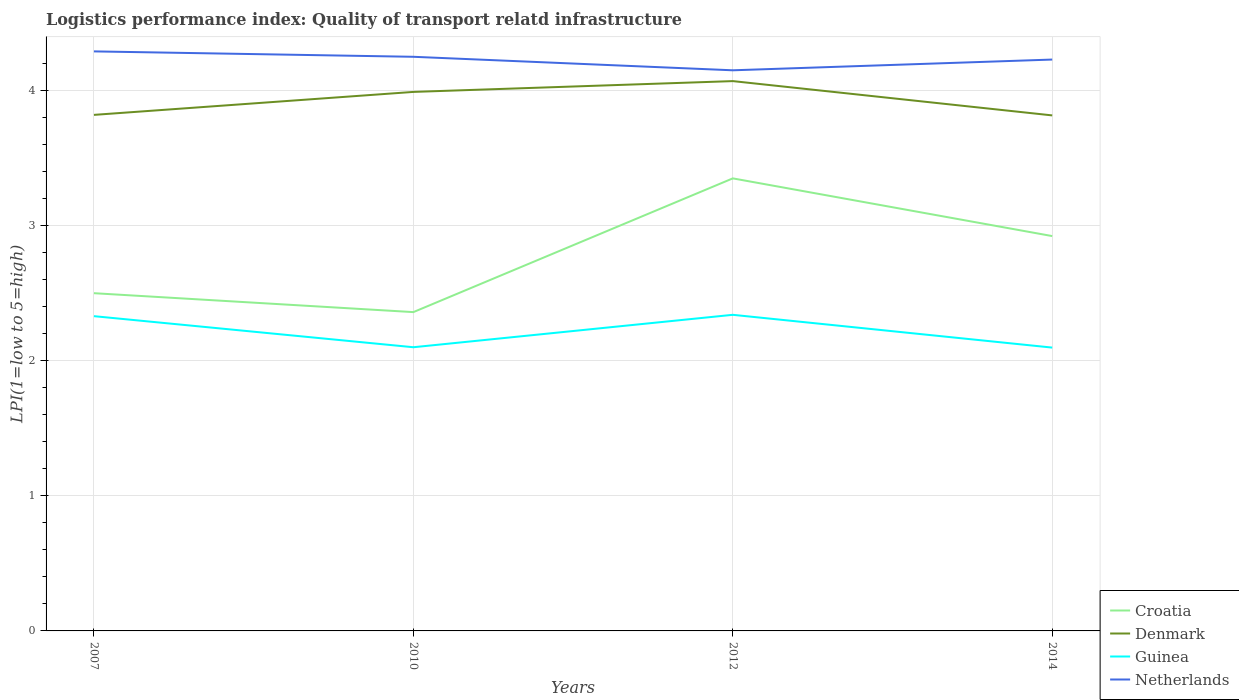How many different coloured lines are there?
Provide a succinct answer. 4. Does the line corresponding to Denmark intersect with the line corresponding to Croatia?
Your answer should be very brief. No. Is the number of lines equal to the number of legend labels?
Give a very brief answer. Yes. Across all years, what is the maximum logistics performance index in Denmark?
Offer a terse response. 3.82. What is the total logistics performance index in Netherlands in the graph?
Make the answer very short. -0.08. What is the difference between the highest and the second highest logistics performance index in Denmark?
Make the answer very short. 0.25. Is the logistics performance index in Guinea strictly greater than the logistics performance index in Denmark over the years?
Your response must be concise. Yes. Does the graph contain any zero values?
Offer a terse response. No. Does the graph contain grids?
Your response must be concise. Yes. How are the legend labels stacked?
Your answer should be very brief. Vertical. What is the title of the graph?
Provide a short and direct response. Logistics performance index: Quality of transport relatd infrastructure. Does "Argentina" appear as one of the legend labels in the graph?
Make the answer very short. No. What is the label or title of the X-axis?
Your answer should be compact. Years. What is the label or title of the Y-axis?
Your answer should be very brief. LPI(1=low to 5=high). What is the LPI(1=low to 5=high) of Denmark in 2007?
Provide a succinct answer. 3.82. What is the LPI(1=low to 5=high) of Guinea in 2007?
Your answer should be very brief. 2.33. What is the LPI(1=low to 5=high) of Netherlands in 2007?
Ensure brevity in your answer.  4.29. What is the LPI(1=low to 5=high) of Croatia in 2010?
Provide a succinct answer. 2.36. What is the LPI(1=low to 5=high) of Denmark in 2010?
Provide a succinct answer. 3.99. What is the LPI(1=low to 5=high) in Netherlands in 2010?
Your answer should be compact. 4.25. What is the LPI(1=low to 5=high) of Croatia in 2012?
Your response must be concise. 3.35. What is the LPI(1=low to 5=high) of Denmark in 2012?
Your answer should be very brief. 4.07. What is the LPI(1=low to 5=high) of Guinea in 2012?
Offer a terse response. 2.34. What is the LPI(1=low to 5=high) in Netherlands in 2012?
Provide a succinct answer. 4.15. What is the LPI(1=low to 5=high) of Croatia in 2014?
Make the answer very short. 2.92. What is the LPI(1=low to 5=high) in Denmark in 2014?
Give a very brief answer. 3.82. What is the LPI(1=low to 5=high) in Guinea in 2014?
Your answer should be compact. 2.1. What is the LPI(1=low to 5=high) in Netherlands in 2014?
Ensure brevity in your answer.  4.23. Across all years, what is the maximum LPI(1=low to 5=high) of Croatia?
Your response must be concise. 3.35. Across all years, what is the maximum LPI(1=low to 5=high) of Denmark?
Keep it short and to the point. 4.07. Across all years, what is the maximum LPI(1=low to 5=high) in Guinea?
Your answer should be compact. 2.34. Across all years, what is the maximum LPI(1=low to 5=high) in Netherlands?
Make the answer very short. 4.29. Across all years, what is the minimum LPI(1=low to 5=high) in Croatia?
Your response must be concise. 2.36. Across all years, what is the minimum LPI(1=low to 5=high) of Denmark?
Give a very brief answer. 3.82. Across all years, what is the minimum LPI(1=low to 5=high) of Guinea?
Offer a terse response. 2.1. Across all years, what is the minimum LPI(1=low to 5=high) in Netherlands?
Your response must be concise. 4.15. What is the total LPI(1=low to 5=high) in Croatia in the graph?
Your answer should be compact. 11.13. What is the total LPI(1=low to 5=high) in Denmark in the graph?
Offer a terse response. 15.7. What is the total LPI(1=low to 5=high) of Guinea in the graph?
Provide a succinct answer. 8.87. What is the total LPI(1=low to 5=high) of Netherlands in the graph?
Your answer should be very brief. 16.92. What is the difference between the LPI(1=low to 5=high) in Croatia in 2007 and that in 2010?
Make the answer very short. 0.14. What is the difference between the LPI(1=low to 5=high) in Denmark in 2007 and that in 2010?
Give a very brief answer. -0.17. What is the difference between the LPI(1=low to 5=high) in Guinea in 2007 and that in 2010?
Offer a very short reply. 0.23. What is the difference between the LPI(1=low to 5=high) in Croatia in 2007 and that in 2012?
Provide a succinct answer. -0.85. What is the difference between the LPI(1=low to 5=high) of Denmark in 2007 and that in 2012?
Keep it short and to the point. -0.25. What is the difference between the LPI(1=low to 5=high) in Guinea in 2007 and that in 2012?
Your answer should be compact. -0.01. What is the difference between the LPI(1=low to 5=high) in Netherlands in 2007 and that in 2012?
Provide a short and direct response. 0.14. What is the difference between the LPI(1=low to 5=high) of Croatia in 2007 and that in 2014?
Provide a succinct answer. -0.42. What is the difference between the LPI(1=low to 5=high) of Denmark in 2007 and that in 2014?
Offer a very short reply. 0. What is the difference between the LPI(1=low to 5=high) in Guinea in 2007 and that in 2014?
Offer a very short reply. 0.23. What is the difference between the LPI(1=low to 5=high) in Netherlands in 2007 and that in 2014?
Keep it short and to the point. 0.06. What is the difference between the LPI(1=low to 5=high) in Croatia in 2010 and that in 2012?
Give a very brief answer. -0.99. What is the difference between the LPI(1=low to 5=high) in Denmark in 2010 and that in 2012?
Ensure brevity in your answer.  -0.08. What is the difference between the LPI(1=low to 5=high) in Guinea in 2010 and that in 2012?
Keep it short and to the point. -0.24. What is the difference between the LPI(1=low to 5=high) in Netherlands in 2010 and that in 2012?
Your response must be concise. 0.1. What is the difference between the LPI(1=low to 5=high) of Croatia in 2010 and that in 2014?
Offer a terse response. -0.56. What is the difference between the LPI(1=low to 5=high) of Denmark in 2010 and that in 2014?
Offer a very short reply. 0.17. What is the difference between the LPI(1=low to 5=high) of Guinea in 2010 and that in 2014?
Provide a short and direct response. 0. What is the difference between the LPI(1=low to 5=high) of Netherlands in 2010 and that in 2014?
Your answer should be compact. 0.02. What is the difference between the LPI(1=low to 5=high) in Croatia in 2012 and that in 2014?
Ensure brevity in your answer.  0.43. What is the difference between the LPI(1=low to 5=high) of Denmark in 2012 and that in 2014?
Ensure brevity in your answer.  0.25. What is the difference between the LPI(1=low to 5=high) in Guinea in 2012 and that in 2014?
Your response must be concise. 0.24. What is the difference between the LPI(1=low to 5=high) of Netherlands in 2012 and that in 2014?
Make the answer very short. -0.08. What is the difference between the LPI(1=low to 5=high) of Croatia in 2007 and the LPI(1=low to 5=high) of Denmark in 2010?
Your answer should be very brief. -1.49. What is the difference between the LPI(1=low to 5=high) in Croatia in 2007 and the LPI(1=low to 5=high) in Netherlands in 2010?
Your answer should be compact. -1.75. What is the difference between the LPI(1=low to 5=high) of Denmark in 2007 and the LPI(1=low to 5=high) of Guinea in 2010?
Your answer should be very brief. 1.72. What is the difference between the LPI(1=low to 5=high) in Denmark in 2007 and the LPI(1=low to 5=high) in Netherlands in 2010?
Keep it short and to the point. -0.43. What is the difference between the LPI(1=low to 5=high) of Guinea in 2007 and the LPI(1=low to 5=high) of Netherlands in 2010?
Keep it short and to the point. -1.92. What is the difference between the LPI(1=low to 5=high) of Croatia in 2007 and the LPI(1=low to 5=high) of Denmark in 2012?
Ensure brevity in your answer.  -1.57. What is the difference between the LPI(1=low to 5=high) of Croatia in 2007 and the LPI(1=low to 5=high) of Guinea in 2012?
Provide a short and direct response. 0.16. What is the difference between the LPI(1=low to 5=high) in Croatia in 2007 and the LPI(1=low to 5=high) in Netherlands in 2012?
Ensure brevity in your answer.  -1.65. What is the difference between the LPI(1=low to 5=high) in Denmark in 2007 and the LPI(1=low to 5=high) in Guinea in 2012?
Ensure brevity in your answer.  1.48. What is the difference between the LPI(1=low to 5=high) of Denmark in 2007 and the LPI(1=low to 5=high) of Netherlands in 2012?
Give a very brief answer. -0.33. What is the difference between the LPI(1=low to 5=high) of Guinea in 2007 and the LPI(1=low to 5=high) of Netherlands in 2012?
Your response must be concise. -1.82. What is the difference between the LPI(1=low to 5=high) of Croatia in 2007 and the LPI(1=low to 5=high) of Denmark in 2014?
Make the answer very short. -1.32. What is the difference between the LPI(1=low to 5=high) of Croatia in 2007 and the LPI(1=low to 5=high) of Guinea in 2014?
Your response must be concise. 0.4. What is the difference between the LPI(1=low to 5=high) in Croatia in 2007 and the LPI(1=low to 5=high) in Netherlands in 2014?
Offer a terse response. -1.73. What is the difference between the LPI(1=low to 5=high) of Denmark in 2007 and the LPI(1=low to 5=high) of Guinea in 2014?
Your response must be concise. 1.72. What is the difference between the LPI(1=low to 5=high) in Denmark in 2007 and the LPI(1=low to 5=high) in Netherlands in 2014?
Your answer should be very brief. -0.41. What is the difference between the LPI(1=low to 5=high) of Guinea in 2007 and the LPI(1=low to 5=high) of Netherlands in 2014?
Offer a very short reply. -1.9. What is the difference between the LPI(1=low to 5=high) of Croatia in 2010 and the LPI(1=low to 5=high) of Denmark in 2012?
Ensure brevity in your answer.  -1.71. What is the difference between the LPI(1=low to 5=high) in Croatia in 2010 and the LPI(1=low to 5=high) in Guinea in 2012?
Ensure brevity in your answer.  0.02. What is the difference between the LPI(1=low to 5=high) of Croatia in 2010 and the LPI(1=low to 5=high) of Netherlands in 2012?
Make the answer very short. -1.79. What is the difference between the LPI(1=low to 5=high) of Denmark in 2010 and the LPI(1=low to 5=high) of Guinea in 2012?
Your answer should be very brief. 1.65. What is the difference between the LPI(1=low to 5=high) in Denmark in 2010 and the LPI(1=low to 5=high) in Netherlands in 2012?
Keep it short and to the point. -0.16. What is the difference between the LPI(1=low to 5=high) of Guinea in 2010 and the LPI(1=low to 5=high) of Netherlands in 2012?
Your answer should be very brief. -2.05. What is the difference between the LPI(1=low to 5=high) of Croatia in 2010 and the LPI(1=low to 5=high) of Denmark in 2014?
Give a very brief answer. -1.46. What is the difference between the LPI(1=low to 5=high) of Croatia in 2010 and the LPI(1=low to 5=high) of Guinea in 2014?
Your response must be concise. 0.26. What is the difference between the LPI(1=low to 5=high) of Croatia in 2010 and the LPI(1=low to 5=high) of Netherlands in 2014?
Your answer should be compact. -1.87. What is the difference between the LPI(1=low to 5=high) of Denmark in 2010 and the LPI(1=low to 5=high) of Guinea in 2014?
Your answer should be very brief. 1.89. What is the difference between the LPI(1=low to 5=high) in Denmark in 2010 and the LPI(1=low to 5=high) in Netherlands in 2014?
Ensure brevity in your answer.  -0.24. What is the difference between the LPI(1=low to 5=high) of Guinea in 2010 and the LPI(1=low to 5=high) of Netherlands in 2014?
Offer a terse response. -2.13. What is the difference between the LPI(1=low to 5=high) of Croatia in 2012 and the LPI(1=low to 5=high) of Denmark in 2014?
Provide a succinct answer. -0.47. What is the difference between the LPI(1=low to 5=high) of Croatia in 2012 and the LPI(1=low to 5=high) of Guinea in 2014?
Offer a very short reply. 1.25. What is the difference between the LPI(1=low to 5=high) of Croatia in 2012 and the LPI(1=low to 5=high) of Netherlands in 2014?
Your response must be concise. -0.88. What is the difference between the LPI(1=low to 5=high) of Denmark in 2012 and the LPI(1=low to 5=high) of Guinea in 2014?
Make the answer very short. 1.97. What is the difference between the LPI(1=low to 5=high) in Denmark in 2012 and the LPI(1=low to 5=high) in Netherlands in 2014?
Make the answer very short. -0.16. What is the difference between the LPI(1=low to 5=high) of Guinea in 2012 and the LPI(1=low to 5=high) of Netherlands in 2014?
Ensure brevity in your answer.  -1.89. What is the average LPI(1=low to 5=high) of Croatia per year?
Your response must be concise. 2.78. What is the average LPI(1=low to 5=high) in Denmark per year?
Ensure brevity in your answer.  3.92. What is the average LPI(1=low to 5=high) of Guinea per year?
Your answer should be compact. 2.22. What is the average LPI(1=low to 5=high) of Netherlands per year?
Your response must be concise. 4.23. In the year 2007, what is the difference between the LPI(1=low to 5=high) in Croatia and LPI(1=low to 5=high) in Denmark?
Offer a terse response. -1.32. In the year 2007, what is the difference between the LPI(1=low to 5=high) of Croatia and LPI(1=low to 5=high) of Guinea?
Ensure brevity in your answer.  0.17. In the year 2007, what is the difference between the LPI(1=low to 5=high) of Croatia and LPI(1=low to 5=high) of Netherlands?
Make the answer very short. -1.79. In the year 2007, what is the difference between the LPI(1=low to 5=high) of Denmark and LPI(1=low to 5=high) of Guinea?
Your answer should be compact. 1.49. In the year 2007, what is the difference between the LPI(1=low to 5=high) in Denmark and LPI(1=low to 5=high) in Netherlands?
Offer a very short reply. -0.47. In the year 2007, what is the difference between the LPI(1=low to 5=high) in Guinea and LPI(1=low to 5=high) in Netherlands?
Offer a very short reply. -1.96. In the year 2010, what is the difference between the LPI(1=low to 5=high) of Croatia and LPI(1=low to 5=high) of Denmark?
Provide a succinct answer. -1.63. In the year 2010, what is the difference between the LPI(1=low to 5=high) in Croatia and LPI(1=low to 5=high) in Guinea?
Offer a very short reply. 0.26. In the year 2010, what is the difference between the LPI(1=low to 5=high) in Croatia and LPI(1=low to 5=high) in Netherlands?
Provide a succinct answer. -1.89. In the year 2010, what is the difference between the LPI(1=low to 5=high) in Denmark and LPI(1=low to 5=high) in Guinea?
Keep it short and to the point. 1.89. In the year 2010, what is the difference between the LPI(1=low to 5=high) of Denmark and LPI(1=low to 5=high) of Netherlands?
Offer a very short reply. -0.26. In the year 2010, what is the difference between the LPI(1=low to 5=high) of Guinea and LPI(1=low to 5=high) of Netherlands?
Your answer should be very brief. -2.15. In the year 2012, what is the difference between the LPI(1=low to 5=high) of Croatia and LPI(1=low to 5=high) of Denmark?
Provide a short and direct response. -0.72. In the year 2012, what is the difference between the LPI(1=low to 5=high) in Croatia and LPI(1=low to 5=high) in Guinea?
Your response must be concise. 1.01. In the year 2012, what is the difference between the LPI(1=low to 5=high) of Denmark and LPI(1=low to 5=high) of Guinea?
Your answer should be compact. 1.73. In the year 2012, what is the difference between the LPI(1=low to 5=high) of Denmark and LPI(1=low to 5=high) of Netherlands?
Offer a very short reply. -0.08. In the year 2012, what is the difference between the LPI(1=low to 5=high) in Guinea and LPI(1=low to 5=high) in Netherlands?
Ensure brevity in your answer.  -1.81. In the year 2014, what is the difference between the LPI(1=low to 5=high) in Croatia and LPI(1=low to 5=high) in Denmark?
Offer a terse response. -0.89. In the year 2014, what is the difference between the LPI(1=low to 5=high) in Croatia and LPI(1=low to 5=high) in Guinea?
Your answer should be compact. 0.83. In the year 2014, what is the difference between the LPI(1=low to 5=high) in Croatia and LPI(1=low to 5=high) in Netherlands?
Provide a succinct answer. -1.31. In the year 2014, what is the difference between the LPI(1=low to 5=high) of Denmark and LPI(1=low to 5=high) of Guinea?
Provide a succinct answer. 1.72. In the year 2014, what is the difference between the LPI(1=low to 5=high) in Denmark and LPI(1=low to 5=high) in Netherlands?
Give a very brief answer. -0.41. In the year 2014, what is the difference between the LPI(1=low to 5=high) of Guinea and LPI(1=low to 5=high) of Netherlands?
Your answer should be very brief. -2.13. What is the ratio of the LPI(1=low to 5=high) of Croatia in 2007 to that in 2010?
Make the answer very short. 1.06. What is the ratio of the LPI(1=low to 5=high) of Denmark in 2007 to that in 2010?
Give a very brief answer. 0.96. What is the ratio of the LPI(1=low to 5=high) in Guinea in 2007 to that in 2010?
Ensure brevity in your answer.  1.11. What is the ratio of the LPI(1=low to 5=high) of Netherlands in 2007 to that in 2010?
Your response must be concise. 1.01. What is the ratio of the LPI(1=low to 5=high) in Croatia in 2007 to that in 2012?
Your answer should be very brief. 0.75. What is the ratio of the LPI(1=low to 5=high) in Denmark in 2007 to that in 2012?
Offer a very short reply. 0.94. What is the ratio of the LPI(1=low to 5=high) of Guinea in 2007 to that in 2012?
Offer a terse response. 1. What is the ratio of the LPI(1=low to 5=high) of Netherlands in 2007 to that in 2012?
Keep it short and to the point. 1.03. What is the ratio of the LPI(1=low to 5=high) of Croatia in 2007 to that in 2014?
Your answer should be very brief. 0.86. What is the ratio of the LPI(1=low to 5=high) in Denmark in 2007 to that in 2014?
Provide a succinct answer. 1. What is the ratio of the LPI(1=low to 5=high) in Guinea in 2007 to that in 2014?
Your response must be concise. 1.11. What is the ratio of the LPI(1=low to 5=high) of Netherlands in 2007 to that in 2014?
Provide a short and direct response. 1.01. What is the ratio of the LPI(1=low to 5=high) in Croatia in 2010 to that in 2012?
Offer a terse response. 0.7. What is the ratio of the LPI(1=low to 5=high) in Denmark in 2010 to that in 2012?
Your answer should be very brief. 0.98. What is the ratio of the LPI(1=low to 5=high) of Guinea in 2010 to that in 2012?
Provide a succinct answer. 0.9. What is the ratio of the LPI(1=low to 5=high) in Netherlands in 2010 to that in 2012?
Ensure brevity in your answer.  1.02. What is the ratio of the LPI(1=low to 5=high) of Croatia in 2010 to that in 2014?
Offer a very short reply. 0.81. What is the ratio of the LPI(1=low to 5=high) in Denmark in 2010 to that in 2014?
Provide a succinct answer. 1.05. What is the ratio of the LPI(1=low to 5=high) in Croatia in 2012 to that in 2014?
Keep it short and to the point. 1.15. What is the ratio of the LPI(1=low to 5=high) of Denmark in 2012 to that in 2014?
Provide a short and direct response. 1.07. What is the ratio of the LPI(1=low to 5=high) in Guinea in 2012 to that in 2014?
Make the answer very short. 1.12. What is the ratio of the LPI(1=low to 5=high) in Netherlands in 2012 to that in 2014?
Offer a very short reply. 0.98. What is the difference between the highest and the second highest LPI(1=low to 5=high) in Croatia?
Your answer should be very brief. 0.43. What is the difference between the highest and the second highest LPI(1=low to 5=high) of Guinea?
Offer a terse response. 0.01. What is the difference between the highest and the second highest LPI(1=low to 5=high) in Netherlands?
Provide a short and direct response. 0.04. What is the difference between the highest and the lowest LPI(1=low to 5=high) of Croatia?
Keep it short and to the point. 0.99. What is the difference between the highest and the lowest LPI(1=low to 5=high) in Denmark?
Make the answer very short. 0.25. What is the difference between the highest and the lowest LPI(1=low to 5=high) in Guinea?
Provide a short and direct response. 0.24. What is the difference between the highest and the lowest LPI(1=low to 5=high) of Netherlands?
Provide a short and direct response. 0.14. 